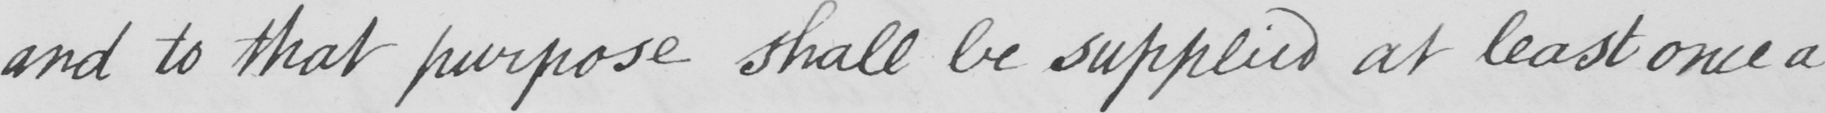Can you read and transcribe this handwriting? and to that purpose shall be supplied at least once a 